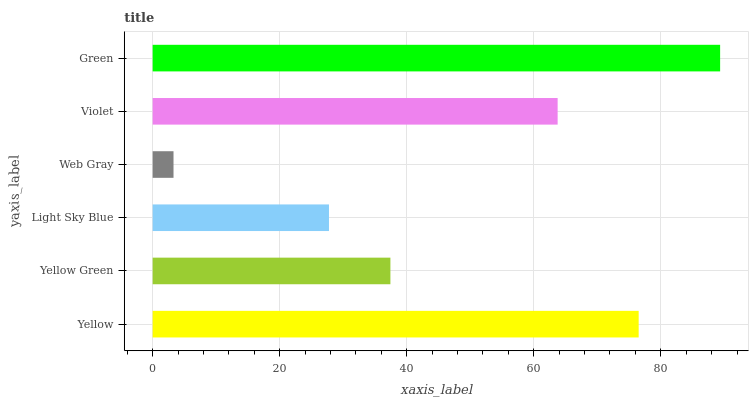Is Web Gray the minimum?
Answer yes or no. Yes. Is Green the maximum?
Answer yes or no. Yes. Is Yellow Green the minimum?
Answer yes or no. No. Is Yellow Green the maximum?
Answer yes or no. No. Is Yellow greater than Yellow Green?
Answer yes or no. Yes. Is Yellow Green less than Yellow?
Answer yes or no. Yes. Is Yellow Green greater than Yellow?
Answer yes or no. No. Is Yellow less than Yellow Green?
Answer yes or no. No. Is Violet the high median?
Answer yes or no. Yes. Is Yellow Green the low median?
Answer yes or no. Yes. Is Web Gray the high median?
Answer yes or no. No. Is Green the low median?
Answer yes or no. No. 